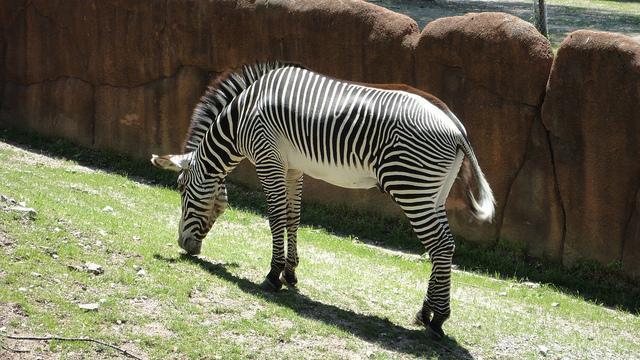How many zebras are shown in this picture?
Give a very brief answer. 1. How many zebras are there?
Give a very brief answer. 1. How many people are typing computer?
Give a very brief answer. 0. 